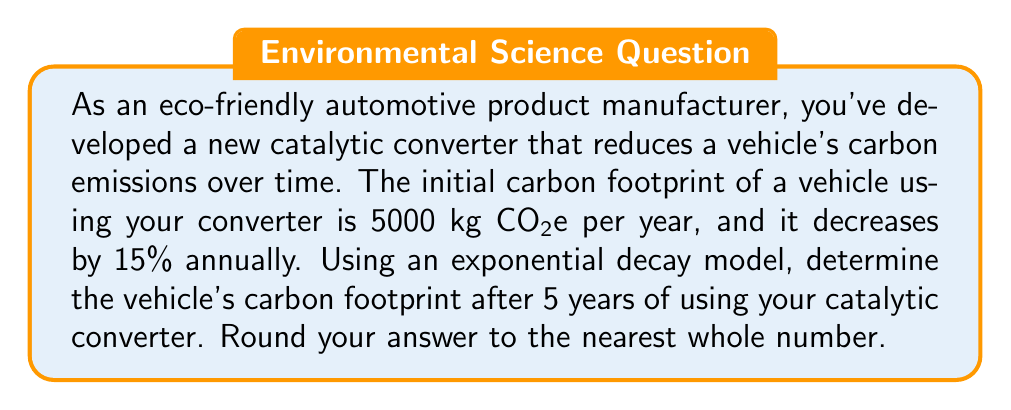Give your solution to this math problem. To solve this problem, we'll use the exponential decay formula:

$$A(t) = A_0 \cdot (1-r)^t$$

Where:
$A(t)$ = Amount after time $t$
$A_0$ = Initial amount
$r$ = Rate of decay (as a decimal)
$t$ = Time period

Given:
$A_0 = 5000$ kg CO2e
$r = 15\% = 0.15$
$t = 5$ years

Let's substitute these values into the formula:

$$A(5) = 5000 \cdot (1-0.15)^5$$

Simplify:
$$A(5) = 5000 \cdot (0.85)^5$$

Calculate the exponent:
$$(0.85)^5 \approx 0.4437$$

Multiply:
$$A(5) = 5000 \cdot 0.4437 \approx 2218.5$$

Rounding to the nearest whole number:
$$A(5) \approx 2219$$ kg CO2e
Answer: 2219 kg CO2e 